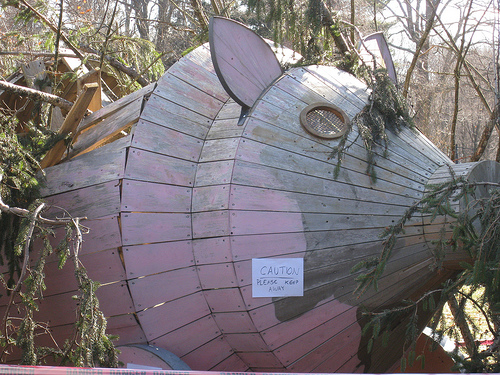<image>
Is the pig above the sign? No. The pig is not positioned above the sign. The vertical arrangement shows a different relationship. 